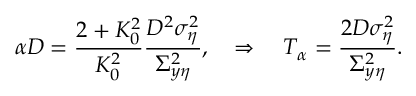<formula> <loc_0><loc_0><loc_500><loc_500>\alpha D = \frac { 2 + K _ { 0 } ^ { 2 } } { K _ { 0 } ^ { 2 } } \frac { D ^ { 2 } \sigma _ { \eta } ^ { 2 } } { \Sigma _ { y \eta } ^ { 2 } } , \quad \Rightarrow \quad T _ { \alpha } = \frac { 2 D \sigma _ { \eta } ^ { 2 } } { \Sigma _ { y \eta } ^ { 2 } } .</formula> 